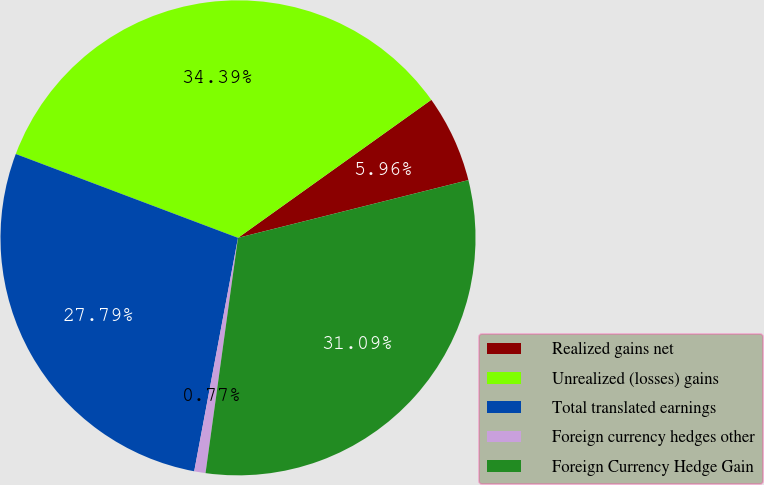<chart> <loc_0><loc_0><loc_500><loc_500><pie_chart><fcel>Realized gains net<fcel>Unrealized (losses) gains<fcel>Total translated earnings<fcel>Foreign currency hedges other<fcel>Foreign Currency Hedge Gain<nl><fcel>5.96%<fcel>34.39%<fcel>27.79%<fcel>0.77%<fcel>31.09%<nl></chart> 